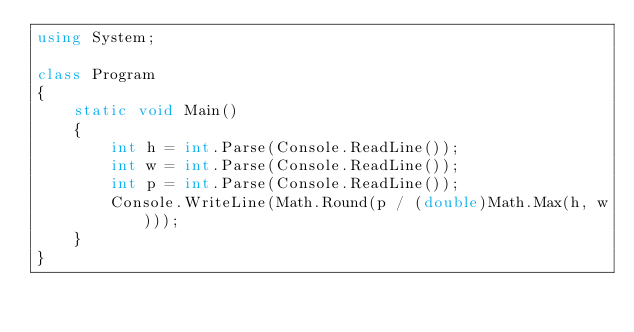<code> <loc_0><loc_0><loc_500><loc_500><_C#_>using System;

class Program
{
    static void Main()
    {
        int h = int.Parse(Console.ReadLine());
        int w = int.Parse(Console.ReadLine());
        int p = int.Parse(Console.ReadLine());
        Console.WriteLine(Math.Round(p / (double)Math.Max(h, w)));
    }
}</code> 